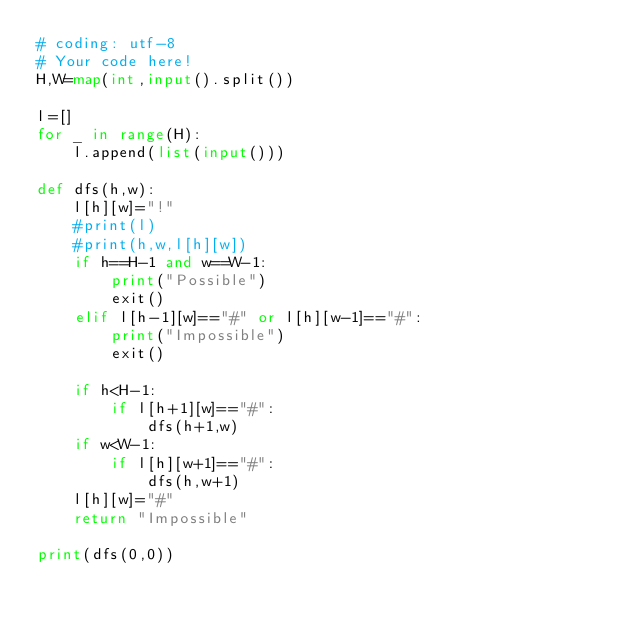<code> <loc_0><loc_0><loc_500><loc_500><_Python_># coding: utf-8
# Your code here!
H,W=map(int,input().split())

l=[]
for _ in range(H):
    l.append(list(input()))

def dfs(h,w):
    l[h][w]="!"
    #print(l)
    #print(h,w,l[h][w])
    if h==H-1 and w==W-1:
        print("Possible")
        exit()
    elif l[h-1][w]=="#" or l[h][w-1]=="#":
        print("Impossible")
        exit()
    
    if h<H-1:
        if l[h+1][w]=="#":
            dfs(h+1,w)
    if w<W-1:
        if l[h][w+1]=="#":
            dfs(h,w+1)
    l[h][w]="#"
    return "Impossible"

print(dfs(0,0))
</code> 